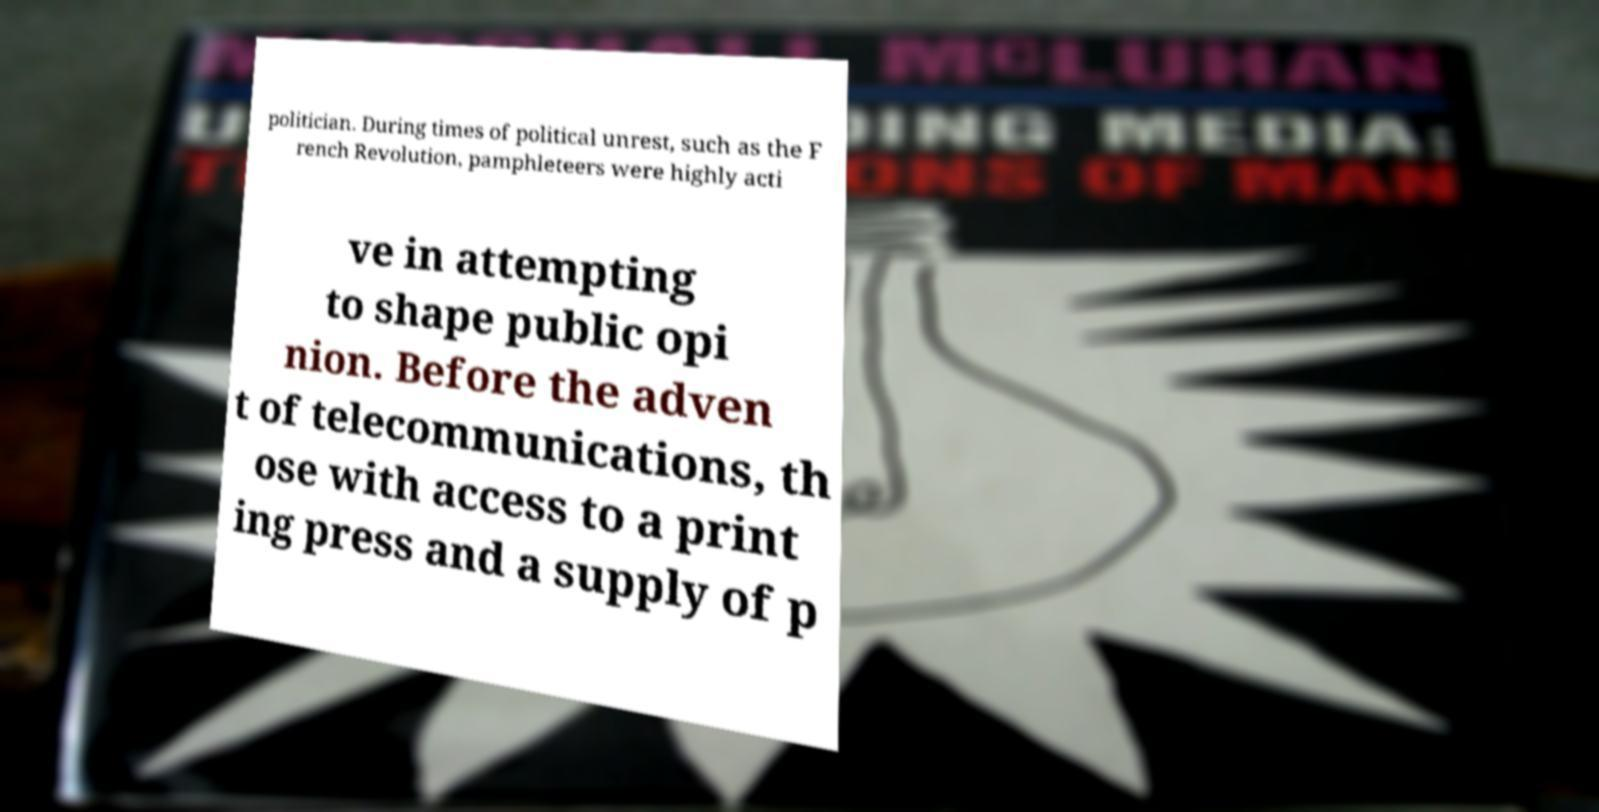There's text embedded in this image that I need extracted. Can you transcribe it verbatim? politician. During times of political unrest, such as the F rench Revolution, pamphleteers were highly acti ve in attempting to shape public opi nion. Before the adven t of telecommunications, th ose with access to a print ing press and a supply of p 